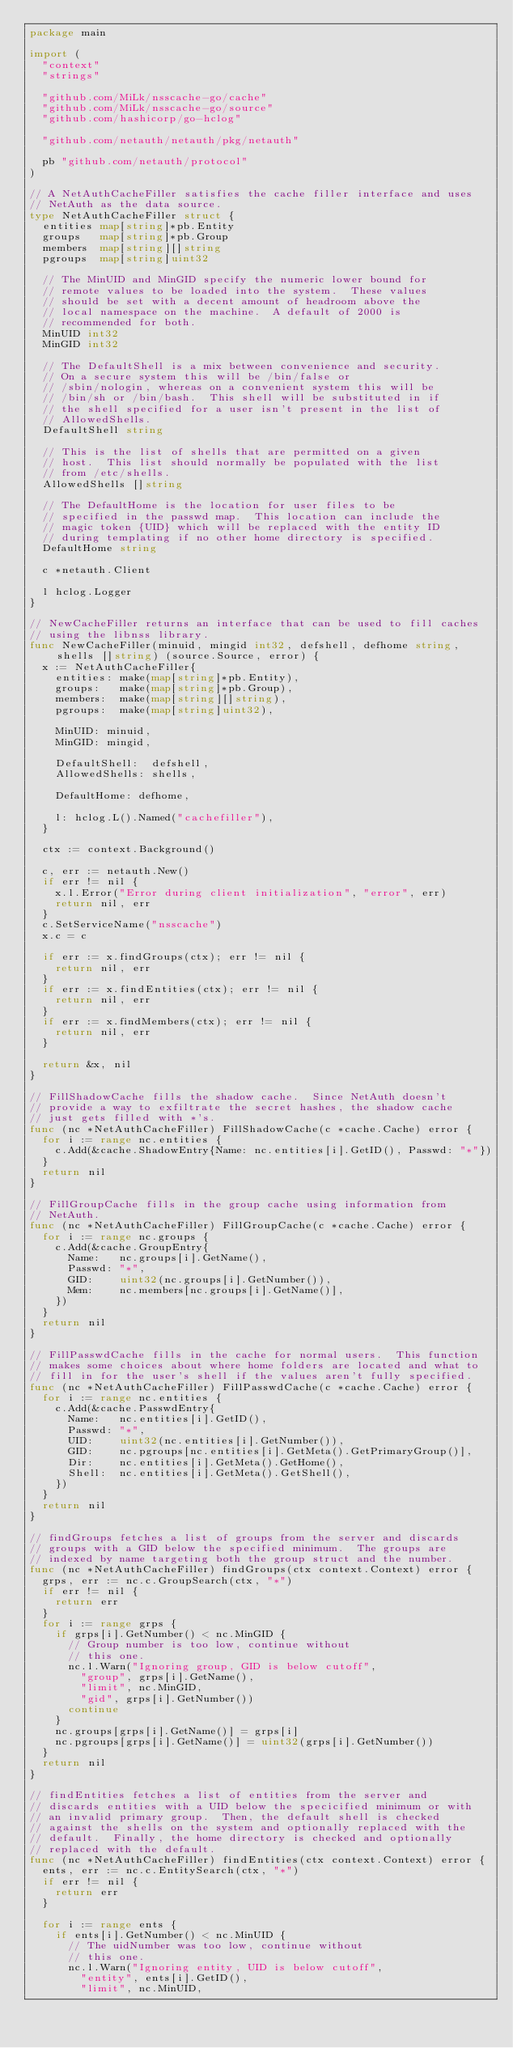<code> <loc_0><loc_0><loc_500><loc_500><_Go_>package main

import (
	"context"
	"strings"

	"github.com/MiLk/nsscache-go/cache"
	"github.com/MiLk/nsscache-go/source"
	"github.com/hashicorp/go-hclog"

	"github.com/netauth/netauth/pkg/netauth"

	pb "github.com/netauth/protocol"
)

// A NetAuthCacheFiller satisfies the cache filler interface and uses
// NetAuth as the data source.
type NetAuthCacheFiller struct {
	entities map[string]*pb.Entity
	groups   map[string]*pb.Group
	members  map[string][]string
	pgroups  map[string]uint32

	// The MinUID and MinGID specify the numeric lower bound for
	// remote values to be loaded into the system.  These values
	// should be set with a decent amount of headroom above the
	// local namespace on the machine.  A default of 2000 is
	// recommended for both.
	MinUID int32
	MinGID int32

	// The DefaultShell is a mix between convenience and security.
	// On a secure system this will be /bin/false or
	// /sbin/nologin, whereas on a convenient system this will be
	// /bin/sh or /bin/bash.  This shell will be substituted in if
	// the shell specified for a user isn't present in the list of
	// AllowedShells.
	DefaultShell string

	// This is the list of shells that are permitted on a given
	// host.  This list should normally be populated with the list
	// from /etc/shells.
	AllowedShells []string

	// The DefaultHome is the location for user files to be
	// specified in the passwd map.  This location can include the
	// magic token {UID} which will be replaced with the entity ID
	// during templating if no other home directory is specified.
	DefaultHome string

	c *netauth.Client

	l hclog.Logger
}

// NewCacheFiller returns an interface that can be used to fill caches
// using the libnss library.
func NewCacheFiller(minuid, mingid int32, defshell, defhome string, shells []string) (source.Source, error) {
	x := NetAuthCacheFiller{
		entities: make(map[string]*pb.Entity),
		groups:   make(map[string]*pb.Group),
		members:  make(map[string][]string),
		pgroups:  make(map[string]uint32),

		MinUID: minuid,
		MinGID: mingid,

		DefaultShell:  defshell,
		AllowedShells: shells,

		DefaultHome: defhome,

		l: hclog.L().Named("cachefiller"),
	}

	ctx := context.Background()

	c, err := netauth.New()
	if err != nil {
		x.l.Error("Error during client initialization", "error", err)
		return nil, err
	}
	c.SetServiceName("nsscache")
	x.c = c

	if err := x.findGroups(ctx); err != nil {
		return nil, err
	}
	if err := x.findEntities(ctx); err != nil {
		return nil, err
	}
	if err := x.findMembers(ctx); err != nil {
		return nil, err
	}

	return &x, nil
}

// FillShadowCache fills the shadow cache.  Since NetAuth doesn't
// provide a way to exfiltrate the secret hashes, the shadow cache
// just gets filled with *'s.
func (nc *NetAuthCacheFiller) FillShadowCache(c *cache.Cache) error {
	for i := range nc.entities {
		c.Add(&cache.ShadowEntry{Name: nc.entities[i].GetID(), Passwd: "*"})
	}
	return nil
}

// FillGroupCache fills in the group cache using information from
// NetAuth.
func (nc *NetAuthCacheFiller) FillGroupCache(c *cache.Cache) error {
	for i := range nc.groups {
		c.Add(&cache.GroupEntry{
			Name:   nc.groups[i].GetName(),
			Passwd: "*",
			GID:    uint32(nc.groups[i].GetNumber()),
			Mem:    nc.members[nc.groups[i].GetName()],
		})
	}
	return nil
}

// FillPasswdCache fills in the cache for normal users.  This function
// makes some choices about where home folders are located and what to
// fill in for the user's shell if the values aren't fully specified.
func (nc *NetAuthCacheFiller) FillPasswdCache(c *cache.Cache) error {
	for i := range nc.entities {
		c.Add(&cache.PasswdEntry{
			Name:   nc.entities[i].GetID(),
			Passwd: "*",
			UID:    uint32(nc.entities[i].GetNumber()),
			GID:    nc.pgroups[nc.entities[i].GetMeta().GetPrimaryGroup()],
			Dir:    nc.entities[i].GetMeta().GetHome(),
			Shell:  nc.entities[i].GetMeta().GetShell(),
		})
	}
	return nil
}

// findGroups fetches a list of groups from the server and discards
// groups with a GID below the specified minimum.  The groups are
// indexed by name targeting both the group struct and the number.
func (nc *NetAuthCacheFiller) findGroups(ctx context.Context) error {
	grps, err := nc.c.GroupSearch(ctx, "*")
	if err != nil {
		return err
	}
	for i := range grps {
		if grps[i].GetNumber() < nc.MinGID {
			// Group number is too low, continue without
			// this one.
			nc.l.Warn("Ignoring group, GID is below cutoff",
				"group", grps[i].GetName(),
				"limit", nc.MinGID,
				"gid", grps[i].GetNumber())
			continue
		}
		nc.groups[grps[i].GetName()] = grps[i]
		nc.pgroups[grps[i].GetName()] = uint32(grps[i].GetNumber())
	}
	return nil
}

// findEntities fetches a list of entities from the server and
// discards entities with a UID below the specicified minimum or with
// an invalid primary group.  Then, the default shell is checked
// against the shells on the system and optionally replaced with the
// default.  Finally, the home directory is checked and optionally
// replaced with the default.
func (nc *NetAuthCacheFiller) findEntities(ctx context.Context) error {
	ents, err := nc.c.EntitySearch(ctx, "*")
	if err != nil {
		return err
	}

	for i := range ents {
		if ents[i].GetNumber() < nc.MinUID {
			// The uidNumber was too low, continue without
			// this one.
			nc.l.Warn("Ignoring entity, UID is below cutoff",
				"entity", ents[i].GetID(),
				"limit", nc.MinUID,</code> 